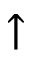Convert formula to latex. <formula><loc_0><loc_0><loc_500><loc_500>\uparrow</formula> 